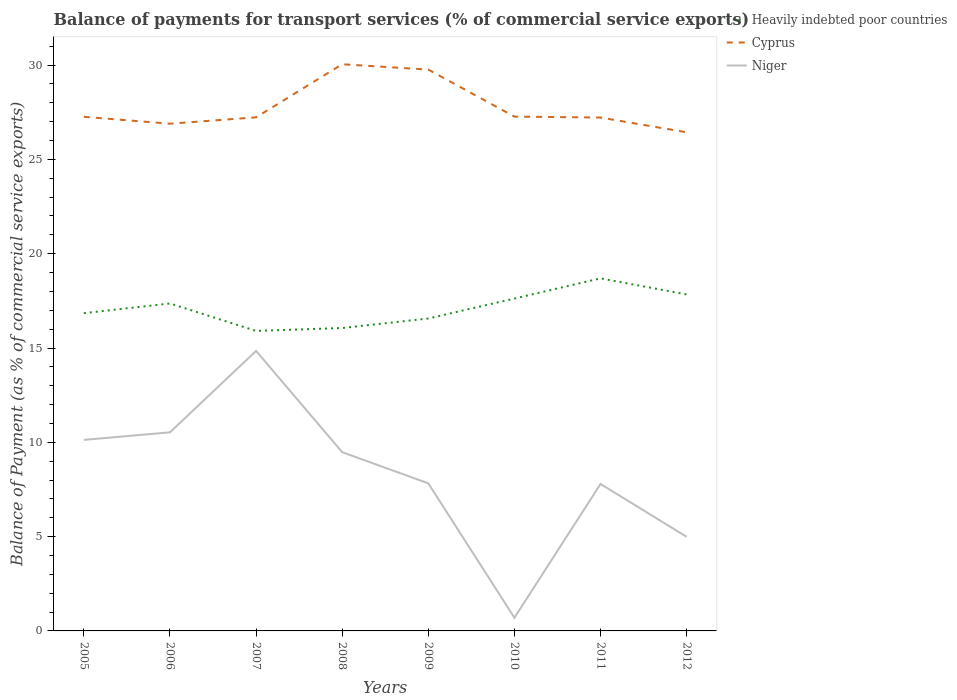How many different coloured lines are there?
Offer a very short reply. 3. Does the line corresponding to Cyprus intersect with the line corresponding to Niger?
Your answer should be very brief. No. Across all years, what is the maximum balance of payments for transport services in Heavily indebted poor countries?
Your answer should be compact. 15.91. In which year was the balance of payments for transport services in Heavily indebted poor countries maximum?
Give a very brief answer. 2007. What is the total balance of payments for transport services in Cyprus in the graph?
Provide a short and direct response. 2.54. What is the difference between the highest and the second highest balance of payments for transport services in Cyprus?
Offer a very short reply. 3.61. Is the balance of payments for transport services in Heavily indebted poor countries strictly greater than the balance of payments for transport services in Cyprus over the years?
Ensure brevity in your answer.  Yes. Are the values on the major ticks of Y-axis written in scientific E-notation?
Ensure brevity in your answer.  No. Does the graph contain any zero values?
Your response must be concise. No. Does the graph contain grids?
Your answer should be very brief. No. Where does the legend appear in the graph?
Ensure brevity in your answer.  Top right. What is the title of the graph?
Provide a short and direct response. Balance of payments for transport services (% of commercial service exports). What is the label or title of the X-axis?
Provide a succinct answer. Years. What is the label or title of the Y-axis?
Offer a terse response. Balance of Payment (as % of commercial service exports). What is the Balance of Payment (as % of commercial service exports) in Heavily indebted poor countries in 2005?
Give a very brief answer. 16.85. What is the Balance of Payment (as % of commercial service exports) of Cyprus in 2005?
Give a very brief answer. 27.26. What is the Balance of Payment (as % of commercial service exports) in Niger in 2005?
Your answer should be very brief. 10.13. What is the Balance of Payment (as % of commercial service exports) in Heavily indebted poor countries in 2006?
Give a very brief answer. 17.36. What is the Balance of Payment (as % of commercial service exports) of Cyprus in 2006?
Offer a terse response. 26.89. What is the Balance of Payment (as % of commercial service exports) in Niger in 2006?
Your answer should be compact. 10.53. What is the Balance of Payment (as % of commercial service exports) of Heavily indebted poor countries in 2007?
Make the answer very short. 15.91. What is the Balance of Payment (as % of commercial service exports) in Cyprus in 2007?
Give a very brief answer. 27.23. What is the Balance of Payment (as % of commercial service exports) of Niger in 2007?
Ensure brevity in your answer.  14.85. What is the Balance of Payment (as % of commercial service exports) in Heavily indebted poor countries in 2008?
Your answer should be compact. 16.06. What is the Balance of Payment (as % of commercial service exports) of Cyprus in 2008?
Your answer should be very brief. 30.05. What is the Balance of Payment (as % of commercial service exports) in Niger in 2008?
Offer a very short reply. 9.48. What is the Balance of Payment (as % of commercial service exports) of Heavily indebted poor countries in 2009?
Ensure brevity in your answer.  16.57. What is the Balance of Payment (as % of commercial service exports) of Cyprus in 2009?
Ensure brevity in your answer.  29.76. What is the Balance of Payment (as % of commercial service exports) of Niger in 2009?
Your answer should be very brief. 7.82. What is the Balance of Payment (as % of commercial service exports) of Heavily indebted poor countries in 2010?
Your response must be concise. 17.62. What is the Balance of Payment (as % of commercial service exports) of Cyprus in 2010?
Your response must be concise. 27.27. What is the Balance of Payment (as % of commercial service exports) of Niger in 2010?
Give a very brief answer. 0.7. What is the Balance of Payment (as % of commercial service exports) in Heavily indebted poor countries in 2011?
Provide a succinct answer. 18.69. What is the Balance of Payment (as % of commercial service exports) of Cyprus in 2011?
Your answer should be very brief. 27.22. What is the Balance of Payment (as % of commercial service exports) of Niger in 2011?
Offer a very short reply. 7.79. What is the Balance of Payment (as % of commercial service exports) of Heavily indebted poor countries in 2012?
Offer a terse response. 17.84. What is the Balance of Payment (as % of commercial service exports) of Cyprus in 2012?
Offer a very short reply. 26.44. What is the Balance of Payment (as % of commercial service exports) of Niger in 2012?
Make the answer very short. 4.99. Across all years, what is the maximum Balance of Payment (as % of commercial service exports) in Heavily indebted poor countries?
Provide a short and direct response. 18.69. Across all years, what is the maximum Balance of Payment (as % of commercial service exports) of Cyprus?
Your response must be concise. 30.05. Across all years, what is the maximum Balance of Payment (as % of commercial service exports) in Niger?
Provide a succinct answer. 14.85. Across all years, what is the minimum Balance of Payment (as % of commercial service exports) in Heavily indebted poor countries?
Make the answer very short. 15.91. Across all years, what is the minimum Balance of Payment (as % of commercial service exports) in Cyprus?
Provide a short and direct response. 26.44. Across all years, what is the minimum Balance of Payment (as % of commercial service exports) in Niger?
Your response must be concise. 0.7. What is the total Balance of Payment (as % of commercial service exports) of Heavily indebted poor countries in the graph?
Offer a very short reply. 136.9. What is the total Balance of Payment (as % of commercial service exports) of Cyprus in the graph?
Give a very brief answer. 222.12. What is the total Balance of Payment (as % of commercial service exports) of Niger in the graph?
Your response must be concise. 66.29. What is the difference between the Balance of Payment (as % of commercial service exports) in Heavily indebted poor countries in 2005 and that in 2006?
Offer a very short reply. -0.51. What is the difference between the Balance of Payment (as % of commercial service exports) of Cyprus in 2005 and that in 2006?
Your answer should be compact. 0.36. What is the difference between the Balance of Payment (as % of commercial service exports) in Niger in 2005 and that in 2006?
Your answer should be very brief. -0.4. What is the difference between the Balance of Payment (as % of commercial service exports) of Heavily indebted poor countries in 2005 and that in 2007?
Keep it short and to the point. 0.94. What is the difference between the Balance of Payment (as % of commercial service exports) of Cyprus in 2005 and that in 2007?
Keep it short and to the point. 0.03. What is the difference between the Balance of Payment (as % of commercial service exports) in Niger in 2005 and that in 2007?
Your response must be concise. -4.72. What is the difference between the Balance of Payment (as % of commercial service exports) of Heavily indebted poor countries in 2005 and that in 2008?
Offer a very short reply. 0.79. What is the difference between the Balance of Payment (as % of commercial service exports) of Cyprus in 2005 and that in 2008?
Ensure brevity in your answer.  -2.79. What is the difference between the Balance of Payment (as % of commercial service exports) in Niger in 2005 and that in 2008?
Give a very brief answer. 0.65. What is the difference between the Balance of Payment (as % of commercial service exports) in Heavily indebted poor countries in 2005 and that in 2009?
Your answer should be compact. 0.28. What is the difference between the Balance of Payment (as % of commercial service exports) in Cyprus in 2005 and that in 2009?
Give a very brief answer. -2.5. What is the difference between the Balance of Payment (as % of commercial service exports) in Niger in 2005 and that in 2009?
Give a very brief answer. 2.3. What is the difference between the Balance of Payment (as % of commercial service exports) in Heavily indebted poor countries in 2005 and that in 2010?
Your answer should be very brief. -0.78. What is the difference between the Balance of Payment (as % of commercial service exports) in Cyprus in 2005 and that in 2010?
Give a very brief answer. -0.01. What is the difference between the Balance of Payment (as % of commercial service exports) in Niger in 2005 and that in 2010?
Keep it short and to the point. 9.43. What is the difference between the Balance of Payment (as % of commercial service exports) of Heavily indebted poor countries in 2005 and that in 2011?
Keep it short and to the point. -1.85. What is the difference between the Balance of Payment (as % of commercial service exports) in Cyprus in 2005 and that in 2011?
Keep it short and to the point. 0.04. What is the difference between the Balance of Payment (as % of commercial service exports) of Niger in 2005 and that in 2011?
Your answer should be very brief. 2.34. What is the difference between the Balance of Payment (as % of commercial service exports) in Heavily indebted poor countries in 2005 and that in 2012?
Ensure brevity in your answer.  -0.99. What is the difference between the Balance of Payment (as % of commercial service exports) of Cyprus in 2005 and that in 2012?
Make the answer very short. 0.82. What is the difference between the Balance of Payment (as % of commercial service exports) of Niger in 2005 and that in 2012?
Make the answer very short. 5.14. What is the difference between the Balance of Payment (as % of commercial service exports) in Heavily indebted poor countries in 2006 and that in 2007?
Provide a short and direct response. 1.45. What is the difference between the Balance of Payment (as % of commercial service exports) of Cyprus in 2006 and that in 2007?
Offer a terse response. -0.34. What is the difference between the Balance of Payment (as % of commercial service exports) of Niger in 2006 and that in 2007?
Keep it short and to the point. -4.32. What is the difference between the Balance of Payment (as % of commercial service exports) in Cyprus in 2006 and that in 2008?
Provide a succinct answer. -3.15. What is the difference between the Balance of Payment (as % of commercial service exports) in Niger in 2006 and that in 2008?
Provide a succinct answer. 1.05. What is the difference between the Balance of Payment (as % of commercial service exports) in Heavily indebted poor countries in 2006 and that in 2009?
Your answer should be very brief. 0.79. What is the difference between the Balance of Payment (as % of commercial service exports) of Cyprus in 2006 and that in 2009?
Make the answer very short. -2.87. What is the difference between the Balance of Payment (as % of commercial service exports) of Niger in 2006 and that in 2009?
Give a very brief answer. 2.71. What is the difference between the Balance of Payment (as % of commercial service exports) of Heavily indebted poor countries in 2006 and that in 2010?
Your answer should be very brief. -0.26. What is the difference between the Balance of Payment (as % of commercial service exports) in Cyprus in 2006 and that in 2010?
Provide a short and direct response. -0.38. What is the difference between the Balance of Payment (as % of commercial service exports) of Niger in 2006 and that in 2010?
Offer a terse response. 9.83. What is the difference between the Balance of Payment (as % of commercial service exports) of Heavily indebted poor countries in 2006 and that in 2011?
Your answer should be compact. -1.33. What is the difference between the Balance of Payment (as % of commercial service exports) in Cyprus in 2006 and that in 2011?
Offer a terse response. -0.33. What is the difference between the Balance of Payment (as % of commercial service exports) of Niger in 2006 and that in 2011?
Your response must be concise. 2.74. What is the difference between the Balance of Payment (as % of commercial service exports) in Heavily indebted poor countries in 2006 and that in 2012?
Provide a short and direct response. -0.48. What is the difference between the Balance of Payment (as % of commercial service exports) in Cyprus in 2006 and that in 2012?
Your response must be concise. 0.45. What is the difference between the Balance of Payment (as % of commercial service exports) of Niger in 2006 and that in 2012?
Make the answer very short. 5.54. What is the difference between the Balance of Payment (as % of commercial service exports) of Heavily indebted poor countries in 2007 and that in 2008?
Make the answer very short. -0.15. What is the difference between the Balance of Payment (as % of commercial service exports) in Cyprus in 2007 and that in 2008?
Keep it short and to the point. -2.81. What is the difference between the Balance of Payment (as % of commercial service exports) of Niger in 2007 and that in 2008?
Make the answer very short. 5.37. What is the difference between the Balance of Payment (as % of commercial service exports) of Heavily indebted poor countries in 2007 and that in 2009?
Offer a terse response. -0.66. What is the difference between the Balance of Payment (as % of commercial service exports) in Cyprus in 2007 and that in 2009?
Ensure brevity in your answer.  -2.53. What is the difference between the Balance of Payment (as % of commercial service exports) in Niger in 2007 and that in 2009?
Your answer should be compact. 7.02. What is the difference between the Balance of Payment (as % of commercial service exports) in Heavily indebted poor countries in 2007 and that in 2010?
Give a very brief answer. -1.72. What is the difference between the Balance of Payment (as % of commercial service exports) in Cyprus in 2007 and that in 2010?
Your answer should be compact. -0.04. What is the difference between the Balance of Payment (as % of commercial service exports) in Niger in 2007 and that in 2010?
Offer a terse response. 14.15. What is the difference between the Balance of Payment (as % of commercial service exports) of Heavily indebted poor countries in 2007 and that in 2011?
Your answer should be compact. -2.79. What is the difference between the Balance of Payment (as % of commercial service exports) in Cyprus in 2007 and that in 2011?
Ensure brevity in your answer.  0.01. What is the difference between the Balance of Payment (as % of commercial service exports) in Niger in 2007 and that in 2011?
Offer a very short reply. 7.05. What is the difference between the Balance of Payment (as % of commercial service exports) in Heavily indebted poor countries in 2007 and that in 2012?
Provide a succinct answer. -1.93. What is the difference between the Balance of Payment (as % of commercial service exports) in Cyprus in 2007 and that in 2012?
Your answer should be very brief. 0.79. What is the difference between the Balance of Payment (as % of commercial service exports) of Niger in 2007 and that in 2012?
Offer a very short reply. 9.86. What is the difference between the Balance of Payment (as % of commercial service exports) in Heavily indebted poor countries in 2008 and that in 2009?
Your response must be concise. -0.51. What is the difference between the Balance of Payment (as % of commercial service exports) in Cyprus in 2008 and that in 2009?
Provide a short and direct response. 0.28. What is the difference between the Balance of Payment (as % of commercial service exports) in Niger in 2008 and that in 2009?
Give a very brief answer. 1.65. What is the difference between the Balance of Payment (as % of commercial service exports) in Heavily indebted poor countries in 2008 and that in 2010?
Offer a terse response. -1.56. What is the difference between the Balance of Payment (as % of commercial service exports) of Cyprus in 2008 and that in 2010?
Make the answer very short. 2.78. What is the difference between the Balance of Payment (as % of commercial service exports) of Niger in 2008 and that in 2010?
Provide a short and direct response. 8.78. What is the difference between the Balance of Payment (as % of commercial service exports) of Heavily indebted poor countries in 2008 and that in 2011?
Your response must be concise. -2.63. What is the difference between the Balance of Payment (as % of commercial service exports) in Cyprus in 2008 and that in 2011?
Give a very brief answer. 2.83. What is the difference between the Balance of Payment (as % of commercial service exports) of Niger in 2008 and that in 2011?
Offer a terse response. 1.69. What is the difference between the Balance of Payment (as % of commercial service exports) in Heavily indebted poor countries in 2008 and that in 2012?
Your response must be concise. -1.78. What is the difference between the Balance of Payment (as % of commercial service exports) in Cyprus in 2008 and that in 2012?
Make the answer very short. 3.61. What is the difference between the Balance of Payment (as % of commercial service exports) of Niger in 2008 and that in 2012?
Offer a terse response. 4.49. What is the difference between the Balance of Payment (as % of commercial service exports) in Heavily indebted poor countries in 2009 and that in 2010?
Offer a terse response. -1.06. What is the difference between the Balance of Payment (as % of commercial service exports) in Cyprus in 2009 and that in 2010?
Your response must be concise. 2.49. What is the difference between the Balance of Payment (as % of commercial service exports) in Niger in 2009 and that in 2010?
Give a very brief answer. 7.12. What is the difference between the Balance of Payment (as % of commercial service exports) of Heavily indebted poor countries in 2009 and that in 2011?
Make the answer very short. -2.13. What is the difference between the Balance of Payment (as % of commercial service exports) of Cyprus in 2009 and that in 2011?
Provide a short and direct response. 2.54. What is the difference between the Balance of Payment (as % of commercial service exports) in Niger in 2009 and that in 2011?
Keep it short and to the point. 0.03. What is the difference between the Balance of Payment (as % of commercial service exports) in Heavily indebted poor countries in 2009 and that in 2012?
Offer a terse response. -1.27. What is the difference between the Balance of Payment (as % of commercial service exports) of Cyprus in 2009 and that in 2012?
Make the answer very short. 3.32. What is the difference between the Balance of Payment (as % of commercial service exports) in Niger in 2009 and that in 2012?
Your answer should be very brief. 2.83. What is the difference between the Balance of Payment (as % of commercial service exports) of Heavily indebted poor countries in 2010 and that in 2011?
Your answer should be compact. -1.07. What is the difference between the Balance of Payment (as % of commercial service exports) of Cyprus in 2010 and that in 2011?
Provide a short and direct response. 0.05. What is the difference between the Balance of Payment (as % of commercial service exports) of Niger in 2010 and that in 2011?
Your response must be concise. -7.09. What is the difference between the Balance of Payment (as % of commercial service exports) in Heavily indebted poor countries in 2010 and that in 2012?
Your answer should be compact. -0.22. What is the difference between the Balance of Payment (as % of commercial service exports) of Cyprus in 2010 and that in 2012?
Make the answer very short. 0.83. What is the difference between the Balance of Payment (as % of commercial service exports) in Niger in 2010 and that in 2012?
Ensure brevity in your answer.  -4.29. What is the difference between the Balance of Payment (as % of commercial service exports) of Heavily indebted poor countries in 2011 and that in 2012?
Provide a short and direct response. 0.85. What is the difference between the Balance of Payment (as % of commercial service exports) in Cyprus in 2011 and that in 2012?
Your response must be concise. 0.78. What is the difference between the Balance of Payment (as % of commercial service exports) of Niger in 2011 and that in 2012?
Keep it short and to the point. 2.8. What is the difference between the Balance of Payment (as % of commercial service exports) of Heavily indebted poor countries in 2005 and the Balance of Payment (as % of commercial service exports) of Cyprus in 2006?
Your answer should be compact. -10.05. What is the difference between the Balance of Payment (as % of commercial service exports) in Heavily indebted poor countries in 2005 and the Balance of Payment (as % of commercial service exports) in Niger in 2006?
Your response must be concise. 6.32. What is the difference between the Balance of Payment (as % of commercial service exports) in Cyprus in 2005 and the Balance of Payment (as % of commercial service exports) in Niger in 2006?
Your answer should be compact. 16.73. What is the difference between the Balance of Payment (as % of commercial service exports) of Heavily indebted poor countries in 2005 and the Balance of Payment (as % of commercial service exports) of Cyprus in 2007?
Your response must be concise. -10.38. What is the difference between the Balance of Payment (as % of commercial service exports) in Heavily indebted poor countries in 2005 and the Balance of Payment (as % of commercial service exports) in Niger in 2007?
Your answer should be very brief. 2. What is the difference between the Balance of Payment (as % of commercial service exports) in Cyprus in 2005 and the Balance of Payment (as % of commercial service exports) in Niger in 2007?
Give a very brief answer. 12.41. What is the difference between the Balance of Payment (as % of commercial service exports) of Heavily indebted poor countries in 2005 and the Balance of Payment (as % of commercial service exports) of Cyprus in 2008?
Keep it short and to the point. -13.2. What is the difference between the Balance of Payment (as % of commercial service exports) in Heavily indebted poor countries in 2005 and the Balance of Payment (as % of commercial service exports) in Niger in 2008?
Offer a terse response. 7.37. What is the difference between the Balance of Payment (as % of commercial service exports) in Cyprus in 2005 and the Balance of Payment (as % of commercial service exports) in Niger in 2008?
Make the answer very short. 17.78. What is the difference between the Balance of Payment (as % of commercial service exports) of Heavily indebted poor countries in 2005 and the Balance of Payment (as % of commercial service exports) of Cyprus in 2009?
Provide a succinct answer. -12.91. What is the difference between the Balance of Payment (as % of commercial service exports) of Heavily indebted poor countries in 2005 and the Balance of Payment (as % of commercial service exports) of Niger in 2009?
Your response must be concise. 9.02. What is the difference between the Balance of Payment (as % of commercial service exports) in Cyprus in 2005 and the Balance of Payment (as % of commercial service exports) in Niger in 2009?
Offer a very short reply. 19.43. What is the difference between the Balance of Payment (as % of commercial service exports) of Heavily indebted poor countries in 2005 and the Balance of Payment (as % of commercial service exports) of Cyprus in 2010?
Provide a succinct answer. -10.42. What is the difference between the Balance of Payment (as % of commercial service exports) in Heavily indebted poor countries in 2005 and the Balance of Payment (as % of commercial service exports) in Niger in 2010?
Give a very brief answer. 16.15. What is the difference between the Balance of Payment (as % of commercial service exports) of Cyprus in 2005 and the Balance of Payment (as % of commercial service exports) of Niger in 2010?
Give a very brief answer. 26.56. What is the difference between the Balance of Payment (as % of commercial service exports) of Heavily indebted poor countries in 2005 and the Balance of Payment (as % of commercial service exports) of Cyprus in 2011?
Offer a terse response. -10.37. What is the difference between the Balance of Payment (as % of commercial service exports) in Heavily indebted poor countries in 2005 and the Balance of Payment (as % of commercial service exports) in Niger in 2011?
Make the answer very short. 9.06. What is the difference between the Balance of Payment (as % of commercial service exports) in Cyprus in 2005 and the Balance of Payment (as % of commercial service exports) in Niger in 2011?
Keep it short and to the point. 19.47. What is the difference between the Balance of Payment (as % of commercial service exports) of Heavily indebted poor countries in 2005 and the Balance of Payment (as % of commercial service exports) of Cyprus in 2012?
Ensure brevity in your answer.  -9.59. What is the difference between the Balance of Payment (as % of commercial service exports) of Heavily indebted poor countries in 2005 and the Balance of Payment (as % of commercial service exports) of Niger in 2012?
Ensure brevity in your answer.  11.86. What is the difference between the Balance of Payment (as % of commercial service exports) in Cyprus in 2005 and the Balance of Payment (as % of commercial service exports) in Niger in 2012?
Keep it short and to the point. 22.27. What is the difference between the Balance of Payment (as % of commercial service exports) of Heavily indebted poor countries in 2006 and the Balance of Payment (as % of commercial service exports) of Cyprus in 2007?
Your answer should be compact. -9.87. What is the difference between the Balance of Payment (as % of commercial service exports) in Heavily indebted poor countries in 2006 and the Balance of Payment (as % of commercial service exports) in Niger in 2007?
Give a very brief answer. 2.51. What is the difference between the Balance of Payment (as % of commercial service exports) of Cyprus in 2006 and the Balance of Payment (as % of commercial service exports) of Niger in 2007?
Your response must be concise. 12.05. What is the difference between the Balance of Payment (as % of commercial service exports) in Heavily indebted poor countries in 2006 and the Balance of Payment (as % of commercial service exports) in Cyprus in 2008?
Your answer should be very brief. -12.69. What is the difference between the Balance of Payment (as % of commercial service exports) in Heavily indebted poor countries in 2006 and the Balance of Payment (as % of commercial service exports) in Niger in 2008?
Provide a succinct answer. 7.88. What is the difference between the Balance of Payment (as % of commercial service exports) of Cyprus in 2006 and the Balance of Payment (as % of commercial service exports) of Niger in 2008?
Offer a terse response. 17.42. What is the difference between the Balance of Payment (as % of commercial service exports) in Heavily indebted poor countries in 2006 and the Balance of Payment (as % of commercial service exports) in Cyprus in 2009?
Your answer should be very brief. -12.4. What is the difference between the Balance of Payment (as % of commercial service exports) in Heavily indebted poor countries in 2006 and the Balance of Payment (as % of commercial service exports) in Niger in 2009?
Your answer should be very brief. 9.54. What is the difference between the Balance of Payment (as % of commercial service exports) of Cyprus in 2006 and the Balance of Payment (as % of commercial service exports) of Niger in 2009?
Offer a very short reply. 19.07. What is the difference between the Balance of Payment (as % of commercial service exports) in Heavily indebted poor countries in 2006 and the Balance of Payment (as % of commercial service exports) in Cyprus in 2010?
Your response must be concise. -9.91. What is the difference between the Balance of Payment (as % of commercial service exports) in Heavily indebted poor countries in 2006 and the Balance of Payment (as % of commercial service exports) in Niger in 2010?
Your answer should be compact. 16.66. What is the difference between the Balance of Payment (as % of commercial service exports) of Cyprus in 2006 and the Balance of Payment (as % of commercial service exports) of Niger in 2010?
Ensure brevity in your answer.  26.19. What is the difference between the Balance of Payment (as % of commercial service exports) in Heavily indebted poor countries in 2006 and the Balance of Payment (as % of commercial service exports) in Cyprus in 2011?
Offer a very short reply. -9.86. What is the difference between the Balance of Payment (as % of commercial service exports) of Heavily indebted poor countries in 2006 and the Balance of Payment (as % of commercial service exports) of Niger in 2011?
Your answer should be very brief. 9.57. What is the difference between the Balance of Payment (as % of commercial service exports) of Cyprus in 2006 and the Balance of Payment (as % of commercial service exports) of Niger in 2011?
Provide a succinct answer. 19.1. What is the difference between the Balance of Payment (as % of commercial service exports) of Heavily indebted poor countries in 2006 and the Balance of Payment (as % of commercial service exports) of Cyprus in 2012?
Provide a succinct answer. -9.08. What is the difference between the Balance of Payment (as % of commercial service exports) of Heavily indebted poor countries in 2006 and the Balance of Payment (as % of commercial service exports) of Niger in 2012?
Your answer should be very brief. 12.37. What is the difference between the Balance of Payment (as % of commercial service exports) of Cyprus in 2006 and the Balance of Payment (as % of commercial service exports) of Niger in 2012?
Provide a short and direct response. 21.9. What is the difference between the Balance of Payment (as % of commercial service exports) of Heavily indebted poor countries in 2007 and the Balance of Payment (as % of commercial service exports) of Cyprus in 2008?
Your answer should be very brief. -14.14. What is the difference between the Balance of Payment (as % of commercial service exports) in Heavily indebted poor countries in 2007 and the Balance of Payment (as % of commercial service exports) in Niger in 2008?
Ensure brevity in your answer.  6.43. What is the difference between the Balance of Payment (as % of commercial service exports) of Cyprus in 2007 and the Balance of Payment (as % of commercial service exports) of Niger in 2008?
Ensure brevity in your answer.  17.75. What is the difference between the Balance of Payment (as % of commercial service exports) in Heavily indebted poor countries in 2007 and the Balance of Payment (as % of commercial service exports) in Cyprus in 2009?
Offer a terse response. -13.86. What is the difference between the Balance of Payment (as % of commercial service exports) in Heavily indebted poor countries in 2007 and the Balance of Payment (as % of commercial service exports) in Niger in 2009?
Ensure brevity in your answer.  8.08. What is the difference between the Balance of Payment (as % of commercial service exports) of Cyprus in 2007 and the Balance of Payment (as % of commercial service exports) of Niger in 2009?
Give a very brief answer. 19.41. What is the difference between the Balance of Payment (as % of commercial service exports) in Heavily indebted poor countries in 2007 and the Balance of Payment (as % of commercial service exports) in Cyprus in 2010?
Your answer should be compact. -11.36. What is the difference between the Balance of Payment (as % of commercial service exports) of Heavily indebted poor countries in 2007 and the Balance of Payment (as % of commercial service exports) of Niger in 2010?
Make the answer very short. 15.21. What is the difference between the Balance of Payment (as % of commercial service exports) of Cyprus in 2007 and the Balance of Payment (as % of commercial service exports) of Niger in 2010?
Your answer should be compact. 26.53. What is the difference between the Balance of Payment (as % of commercial service exports) of Heavily indebted poor countries in 2007 and the Balance of Payment (as % of commercial service exports) of Cyprus in 2011?
Your answer should be very brief. -11.31. What is the difference between the Balance of Payment (as % of commercial service exports) of Heavily indebted poor countries in 2007 and the Balance of Payment (as % of commercial service exports) of Niger in 2011?
Your answer should be very brief. 8.11. What is the difference between the Balance of Payment (as % of commercial service exports) in Cyprus in 2007 and the Balance of Payment (as % of commercial service exports) in Niger in 2011?
Your answer should be very brief. 19.44. What is the difference between the Balance of Payment (as % of commercial service exports) of Heavily indebted poor countries in 2007 and the Balance of Payment (as % of commercial service exports) of Cyprus in 2012?
Keep it short and to the point. -10.53. What is the difference between the Balance of Payment (as % of commercial service exports) in Heavily indebted poor countries in 2007 and the Balance of Payment (as % of commercial service exports) in Niger in 2012?
Your answer should be compact. 10.92. What is the difference between the Balance of Payment (as % of commercial service exports) of Cyprus in 2007 and the Balance of Payment (as % of commercial service exports) of Niger in 2012?
Offer a terse response. 22.24. What is the difference between the Balance of Payment (as % of commercial service exports) in Heavily indebted poor countries in 2008 and the Balance of Payment (as % of commercial service exports) in Cyprus in 2009?
Provide a succinct answer. -13.7. What is the difference between the Balance of Payment (as % of commercial service exports) of Heavily indebted poor countries in 2008 and the Balance of Payment (as % of commercial service exports) of Niger in 2009?
Provide a short and direct response. 8.24. What is the difference between the Balance of Payment (as % of commercial service exports) in Cyprus in 2008 and the Balance of Payment (as % of commercial service exports) in Niger in 2009?
Make the answer very short. 22.22. What is the difference between the Balance of Payment (as % of commercial service exports) of Heavily indebted poor countries in 2008 and the Balance of Payment (as % of commercial service exports) of Cyprus in 2010?
Keep it short and to the point. -11.21. What is the difference between the Balance of Payment (as % of commercial service exports) of Heavily indebted poor countries in 2008 and the Balance of Payment (as % of commercial service exports) of Niger in 2010?
Give a very brief answer. 15.36. What is the difference between the Balance of Payment (as % of commercial service exports) in Cyprus in 2008 and the Balance of Payment (as % of commercial service exports) in Niger in 2010?
Your response must be concise. 29.35. What is the difference between the Balance of Payment (as % of commercial service exports) of Heavily indebted poor countries in 2008 and the Balance of Payment (as % of commercial service exports) of Cyprus in 2011?
Your answer should be very brief. -11.16. What is the difference between the Balance of Payment (as % of commercial service exports) of Heavily indebted poor countries in 2008 and the Balance of Payment (as % of commercial service exports) of Niger in 2011?
Ensure brevity in your answer.  8.27. What is the difference between the Balance of Payment (as % of commercial service exports) of Cyprus in 2008 and the Balance of Payment (as % of commercial service exports) of Niger in 2011?
Give a very brief answer. 22.25. What is the difference between the Balance of Payment (as % of commercial service exports) in Heavily indebted poor countries in 2008 and the Balance of Payment (as % of commercial service exports) in Cyprus in 2012?
Your answer should be very brief. -10.38. What is the difference between the Balance of Payment (as % of commercial service exports) of Heavily indebted poor countries in 2008 and the Balance of Payment (as % of commercial service exports) of Niger in 2012?
Make the answer very short. 11.07. What is the difference between the Balance of Payment (as % of commercial service exports) in Cyprus in 2008 and the Balance of Payment (as % of commercial service exports) in Niger in 2012?
Your response must be concise. 25.06. What is the difference between the Balance of Payment (as % of commercial service exports) of Heavily indebted poor countries in 2009 and the Balance of Payment (as % of commercial service exports) of Cyprus in 2010?
Offer a terse response. -10.7. What is the difference between the Balance of Payment (as % of commercial service exports) of Heavily indebted poor countries in 2009 and the Balance of Payment (as % of commercial service exports) of Niger in 2010?
Give a very brief answer. 15.87. What is the difference between the Balance of Payment (as % of commercial service exports) in Cyprus in 2009 and the Balance of Payment (as % of commercial service exports) in Niger in 2010?
Offer a terse response. 29.06. What is the difference between the Balance of Payment (as % of commercial service exports) of Heavily indebted poor countries in 2009 and the Balance of Payment (as % of commercial service exports) of Cyprus in 2011?
Offer a terse response. -10.65. What is the difference between the Balance of Payment (as % of commercial service exports) in Heavily indebted poor countries in 2009 and the Balance of Payment (as % of commercial service exports) in Niger in 2011?
Your answer should be very brief. 8.77. What is the difference between the Balance of Payment (as % of commercial service exports) in Cyprus in 2009 and the Balance of Payment (as % of commercial service exports) in Niger in 2011?
Provide a succinct answer. 21.97. What is the difference between the Balance of Payment (as % of commercial service exports) in Heavily indebted poor countries in 2009 and the Balance of Payment (as % of commercial service exports) in Cyprus in 2012?
Your answer should be compact. -9.87. What is the difference between the Balance of Payment (as % of commercial service exports) of Heavily indebted poor countries in 2009 and the Balance of Payment (as % of commercial service exports) of Niger in 2012?
Offer a terse response. 11.58. What is the difference between the Balance of Payment (as % of commercial service exports) in Cyprus in 2009 and the Balance of Payment (as % of commercial service exports) in Niger in 2012?
Offer a terse response. 24.77. What is the difference between the Balance of Payment (as % of commercial service exports) in Heavily indebted poor countries in 2010 and the Balance of Payment (as % of commercial service exports) in Cyprus in 2011?
Keep it short and to the point. -9.6. What is the difference between the Balance of Payment (as % of commercial service exports) in Heavily indebted poor countries in 2010 and the Balance of Payment (as % of commercial service exports) in Niger in 2011?
Your response must be concise. 9.83. What is the difference between the Balance of Payment (as % of commercial service exports) of Cyprus in 2010 and the Balance of Payment (as % of commercial service exports) of Niger in 2011?
Ensure brevity in your answer.  19.48. What is the difference between the Balance of Payment (as % of commercial service exports) of Heavily indebted poor countries in 2010 and the Balance of Payment (as % of commercial service exports) of Cyprus in 2012?
Offer a terse response. -8.82. What is the difference between the Balance of Payment (as % of commercial service exports) of Heavily indebted poor countries in 2010 and the Balance of Payment (as % of commercial service exports) of Niger in 2012?
Your answer should be very brief. 12.63. What is the difference between the Balance of Payment (as % of commercial service exports) of Cyprus in 2010 and the Balance of Payment (as % of commercial service exports) of Niger in 2012?
Keep it short and to the point. 22.28. What is the difference between the Balance of Payment (as % of commercial service exports) of Heavily indebted poor countries in 2011 and the Balance of Payment (as % of commercial service exports) of Cyprus in 2012?
Offer a terse response. -7.75. What is the difference between the Balance of Payment (as % of commercial service exports) in Heavily indebted poor countries in 2011 and the Balance of Payment (as % of commercial service exports) in Niger in 2012?
Give a very brief answer. 13.7. What is the difference between the Balance of Payment (as % of commercial service exports) in Cyprus in 2011 and the Balance of Payment (as % of commercial service exports) in Niger in 2012?
Give a very brief answer. 22.23. What is the average Balance of Payment (as % of commercial service exports) in Heavily indebted poor countries per year?
Provide a short and direct response. 17.11. What is the average Balance of Payment (as % of commercial service exports) of Cyprus per year?
Ensure brevity in your answer.  27.76. What is the average Balance of Payment (as % of commercial service exports) in Niger per year?
Give a very brief answer. 8.29. In the year 2005, what is the difference between the Balance of Payment (as % of commercial service exports) in Heavily indebted poor countries and Balance of Payment (as % of commercial service exports) in Cyprus?
Give a very brief answer. -10.41. In the year 2005, what is the difference between the Balance of Payment (as % of commercial service exports) in Heavily indebted poor countries and Balance of Payment (as % of commercial service exports) in Niger?
Provide a succinct answer. 6.72. In the year 2005, what is the difference between the Balance of Payment (as % of commercial service exports) in Cyprus and Balance of Payment (as % of commercial service exports) in Niger?
Give a very brief answer. 17.13. In the year 2006, what is the difference between the Balance of Payment (as % of commercial service exports) in Heavily indebted poor countries and Balance of Payment (as % of commercial service exports) in Cyprus?
Keep it short and to the point. -9.53. In the year 2006, what is the difference between the Balance of Payment (as % of commercial service exports) of Heavily indebted poor countries and Balance of Payment (as % of commercial service exports) of Niger?
Make the answer very short. 6.83. In the year 2006, what is the difference between the Balance of Payment (as % of commercial service exports) of Cyprus and Balance of Payment (as % of commercial service exports) of Niger?
Offer a terse response. 16.36. In the year 2007, what is the difference between the Balance of Payment (as % of commercial service exports) of Heavily indebted poor countries and Balance of Payment (as % of commercial service exports) of Cyprus?
Offer a very short reply. -11.32. In the year 2007, what is the difference between the Balance of Payment (as % of commercial service exports) in Heavily indebted poor countries and Balance of Payment (as % of commercial service exports) in Niger?
Make the answer very short. 1.06. In the year 2007, what is the difference between the Balance of Payment (as % of commercial service exports) in Cyprus and Balance of Payment (as % of commercial service exports) in Niger?
Make the answer very short. 12.38. In the year 2008, what is the difference between the Balance of Payment (as % of commercial service exports) of Heavily indebted poor countries and Balance of Payment (as % of commercial service exports) of Cyprus?
Make the answer very short. -13.99. In the year 2008, what is the difference between the Balance of Payment (as % of commercial service exports) of Heavily indebted poor countries and Balance of Payment (as % of commercial service exports) of Niger?
Provide a short and direct response. 6.58. In the year 2008, what is the difference between the Balance of Payment (as % of commercial service exports) in Cyprus and Balance of Payment (as % of commercial service exports) in Niger?
Provide a succinct answer. 20.57. In the year 2009, what is the difference between the Balance of Payment (as % of commercial service exports) of Heavily indebted poor countries and Balance of Payment (as % of commercial service exports) of Cyprus?
Provide a short and direct response. -13.2. In the year 2009, what is the difference between the Balance of Payment (as % of commercial service exports) in Heavily indebted poor countries and Balance of Payment (as % of commercial service exports) in Niger?
Provide a succinct answer. 8.74. In the year 2009, what is the difference between the Balance of Payment (as % of commercial service exports) of Cyprus and Balance of Payment (as % of commercial service exports) of Niger?
Give a very brief answer. 21.94. In the year 2010, what is the difference between the Balance of Payment (as % of commercial service exports) of Heavily indebted poor countries and Balance of Payment (as % of commercial service exports) of Cyprus?
Your answer should be very brief. -9.65. In the year 2010, what is the difference between the Balance of Payment (as % of commercial service exports) in Heavily indebted poor countries and Balance of Payment (as % of commercial service exports) in Niger?
Keep it short and to the point. 16.92. In the year 2010, what is the difference between the Balance of Payment (as % of commercial service exports) in Cyprus and Balance of Payment (as % of commercial service exports) in Niger?
Your answer should be very brief. 26.57. In the year 2011, what is the difference between the Balance of Payment (as % of commercial service exports) of Heavily indebted poor countries and Balance of Payment (as % of commercial service exports) of Cyprus?
Keep it short and to the point. -8.53. In the year 2011, what is the difference between the Balance of Payment (as % of commercial service exports) in Heavily indebted poor countries and Balance of Payment (as % of commercial service exports) in Niger?
Your answer should be very brief. 10.9. In the year 2011, what is the difference between the Balance of Payment (as % of commercial service exports) in Cyprus and Balance of Payment (as % of commercial service exports) in Niger?
Your answer should be very brief. 19.43. In the year 2012, what is the difference between the Balance of Payment (as % of commercial service exports) of Heavily indebted poor countries and Balance of Payment (as % of commercial service exports) of Cyprus?
Offer a terse response. -8.6. In the year 2012, what is the difference between the Balance of Payment (as % of commercial service exports) in Heavily indebted poor countries and Balance of Payment (as % of commercial service exports) in Niger?
Provide a succinct answer. 12.85. In the year 2012, what is the difference between the Balance of Payment (as % of commercial service exports) in Cyprus and Balance of Payment (as % of commercial service exports) in Niger?
Give a very brief answer. 21.45. What is the ratio of the Balance of Payment (as % of commercial service exports) in Heavily indebted poor countries in 2005 to that in 2006?
Keep it short and to the point. 0.97. What is the ratio of the Balance of Payment (as % of commercial service exports) in Cyprus in 2005 to that in 2006?
Your response must be concise. 1.01. What is the ratio of the Balance of Payment (as % of commercial service exports) in Niger in 2005 to that in 2006?
Give a very brief answer. 0.96. What is the ratio of the Balance of Payment (as % of commercial service exports) of Heavily indebted poor countries in 2005 to that in 2007?
Your answer should be very brief. 1.06. What is the ratio of the Balance of Payment (as % of commercial service exports) in Niger in 2005 to that in 2007?
Keep it short and to the point. 0.68. What is the ratio of the Balance of Payment (as % of commercial service exports) in Heavily indebted poor countries in 2005 to that in 2008?
Provide a succinct answer. 1.05. What is the ratio of the Balance of Payment (as % of commercial service exports) of Cyprus in 2005 to that in 2008?
Provide a succinct answer. 0.91. What is the ratio of the Balance of Payment (as % of commercial service exports) of Niger in 2005 to that in 2008?
Provide a succinct answer. 1.07. What is the ratio of the Balance of Payment (as % of commercial service exports) of Cyprus in 2005 to that in 2009?
Your answer should be compact. 0.92. What is the ratio of the Balance of Payment (as % of commercial service exports) of Niger in 2005 to that in 2009?
Keep it short and to the point. 1.29. What is the ratio of the Balance of Payment (as % of commercial service exports) in Heavily indebted poor countries in 2005 to that in 2010?
Your answer should be compact. 0.96. What is the ratio of the Balance of Payment (as % of commercial service exports) of Cyprus in 2005 to that in 2010?
Offer a terse response. 1. What is the ratio of the Balance of Payment (as % of commercial service exports) of Niger in 2005 to that in 2010?
Ensure brevity in your answer.  14.48. What is the ratio of the Balance of Payment (as % of commercial service exports) in Heavily indebted poor countries in 2005 to that in 2011?
Ensure brevity in your answer.  0.9. What is the ratio of the Balance of Payment (as % of commercial service exports) in Cyprus in 2005 to that in 2011?
Give a very brief answer. 1. What is the ratio of the Balance of Payment (as % of commercial service exports) in Niger in 2005 to that in 2011?
Your response must be concise. 1.3. What is the ratio of the Balance of Payment (as % of commercial service exports) in Heavily indebted poor countries in 2005 to that in 2012?
Your answer should be compact. 0.94. What is the ratio of the Balance of Payment (as % of commercial service exports) in Cyprus in 2005 to that in 2012?
Offer a very short reply. 1.03. What is the ratio of the Balance of Payment (as % of commercial service exports) of Niger in 2005 to that in 2012?
Provide a succinct answer. 2.03. What is the ratio of the Balance of Payment (as % of commercial service exports) in Heavily indebted poor countries in 2006 to that in 2007?
Give a very brief answer. 1.09. What is the ratio of the Balance of Payment (as % of commercial service exports) of Cyprus in 2006 to that in 2007?
Your response must be concise. 0.99. What is the ratio of the Balance of Payment (as % of commercial service exports) in Niger in 2006 to that in 2007?
Make the answer very short. 0.71. What is the ratio of the Balance of Payment (as % of commercial service exports) in Heavily indebted poor countries in 2006 to that in 2008?
Ensure brevity in your answer.  1.08. What is the ratio of the Balance of Payment (as % of commercial service exports) in Cyprus in 2006 to that in 2008?
Offer a terse response. 0.9. What is the ratio of the Balance of Payment (as % of commercial service exports) in Niger in 2006 to that in 2008?
Provide a succinct answer. 1.11. What is the ratio of the Balance of Payment (as % of commercial service exports) in Heavily indebted poor countries in 2006 to that in 2009?
Your response must be concise. 1.05. What is the ratio of the Balance of Payment (as % of commercial service exports) in Cyprus in 2006 to that in 2009?
Offer a very short reply. 0.9. What is the ratio of the Balance of Payment (as % of commercial service exports) in Niger in 2006 to that in 2009?
Ensure brevity in your answer.  1.35. What is the ratio of the Balance of Payment (as % of commercial service exports) in Heavily indebted poor countries in 2006 to that in 2010?
Offer a terse response. 0.99. What is the ratio of the Balance of Payment (as % of commercial service exports) of Cyprus in 2006 to that in 2010?
Give a very brief answer. 0.99. What is the ratio of the Balance of Payment (as % of commercial service exports) in Niger in 2006 to that in 2010?
Your answer should be very brief. 15.05. What is the ratio of the Balance of Payment (as % of commercial service exports) of Heavily indebted poor countries in 2006 to that in 2011?
Provide a succinct answer. 0.93. What is the ratio of the Balance of Payment (as % of commercial service exports) in Niger in 2006 to that in 2011?
Make the answer very short. 1.35. What is the ratio of the Balance of Payment (as % of commercial service exports) of Heavily indebted poor countries in 2006 to that in 2012?
Keep it short and to the point. 0.97. What is the ratio of the Balance of Payment (as % of commercial service exports) of Cyprus in 2006 to that in 2012?
Offer a very short reply. 1.02. What is the ratio of the Balance of Payment (as % of commercial service exports) of Niger in 2006 to that in 2012?
Make the answer very short. 2.11. What is the ratio of the Balance of Payment (as % of commercial service exports) in Heavily indebted poor countries in 2007 to that in 2008?
Give a very brief answer. 0.99. What is the ratio of the Balance of Payment (as % of commercial service exports) of Cyprus in 2007 to that in 2008?
Ensure brevity in your answer.  0.91. What is the ratio of the Balance of Payment (as % of commercial service exports) of Niger in 2007 to that in 2008?
Your answer should be compact. 1.57. What is the ratio of the Balance of Payment (as % of commercial service exports) in Heavily indebted poor countries in 2007 to that in 2009?
Your answer should be compact. 0.96. What is the ratio of the Balance of Payment (as % of commercial service exports) of Cyprus in 2007 to that in 2009?
Make the answer very short. 0.91. What is the ratio of the Balance of Payment (as % of commercial service exports) of Niger in 2007 to that in 2009?
Ensure brevity in your answer.  1.9. What is the ratio of the Balance of Payment (as % of commercial service exports) of Heavily indebted poor countries in 2007 to that in 2010?
Keep it short and to the point. 0.9. What is the ratio of the Balance of Payment (as % of commercial service exports) of Niger in 2007 to that in 2010?
Your response must be concise. 21.22. What is the ratio of the Balance of Payment (as % of commercial service exports) of Heavily indebted poor countries in 2007 to that in 2011?
Make the answer very short. 0.85. What is the ratio of the Balance of Payment (as % of commercial service exports) of Niger in 2007 to that in 2011?
Offer a terse response. 1.91. What is the ratio of the Balance of Payment (as % of commercial service exports) of Heavily indebted poor countries in 2007 to that in 2012?
Your answer should be compact. 0.89. What is the ratio of the Balance of Payment (as % of commercial service exports) of Cyprus in 2007 to that in 2012?
Offer a very short reply. 1.03. What is the ratio of the Balance of Payment (as % of commercial service exports) of Niger in 2007 to that in 2012?
Your answer should be very brief. 2.98. What is the ratio of the Balance of Payment (as % of commercial service exports) in Heavily indebted poor countries in 2008 to that in 2009?
Your answer should be very brief. 0.97. What is the ratio of the Balance of Payment (as % of commercial service exports) of Cyprus in 2008 to that in 2009?
Provide a succinct answer. 1.01. What is the ratio of the Balance of Payment (as % of commercial service exports) of Niger in 2008 to that in 2009?
Provide a short and direct response. 1.21. What is the ratio of the Balance of Payment (as % of commercial service exports) in Heavily indebted poor countries in 2008 to that in 2010?
Provide a succinct answer. 0.91. What is the ratio of the Balance of Payment (as % of commercial service exports) of Cyprus in 2008 to that in 2010?
Your answer should be compact. 1.1. What is the ratio of the Balance of Payment (as % of commercial service exports) of Niger in 2008 to that in 2010?
Provide a succinct answer. 13.55. What is the ratio of the Balance of Payment (as % of commercial service exports) of Heavily indebted poor countries in 2008 to that in 2011?
Offer a very short reply. 0.86. What is the ratio of the Balance of Payment (as % of commercial service exports) in Cyprus in 2008 to that in 2011?
Offer a terse response. 1.1. What is the ratio of the Balance of Payment (as % of commercial service exports) of Niger in 2008 to that in 2011?
Provide a short and direct response. 1.22. What is the ratio of the Balance of Payment (as % of commercial service exports) in Heavily indebted poor countries in 2008 to that in 2012?
Your response must be concise. 0.9. What is the ratio of the Balance of Payment (as % of commercial service exports) in Cyprus in 2008 to that in 2012?
Provide a succinct answer. 1.14. What is the ratio of the Balance of Payment (as % of commercial service exports) in Niger in 2008 to that in 2012?
Your answer should be compact. 1.9. What is the ratio of the Balance of Payment (as % of commercial service exports) of Cyprus in 2009 to that in 2010?
Your response must be concise. 1.09. What is the ratio of the Balance of Payment (as % of commercial service exports) in Niger in 2009 to that in 2010?
Offer a very short reply. 11.18. What is the ratio of the Balance of Payment (as % of commercial service exports) of Heavily indebted poor countries in 2009 to that in 2011?
Provide a short and direct response. 0.89. What is the ratio of the Balance of Payment (as % of commercial service exports) of Cyprus in 2009 to that in 2011?
Make the answer very short. 1.09. What is the ratio of the Balance of Payment (as % of commercial service exports) in Niger in 2009 to that in 2011?
Offer a very short reply. 1. What is the ratio of the Balance of Payment (as % of commercial service exports) of Heavily indebted poor countries in 2009 to that in 2012?
Provide a short and direct response. 0.93. What is the ratio of the Balance of Payment (as % of commercial service exports) in Cyprus in 2009 to that in 2012?
Give a very brief answer. 1.13. What is the ratio of the Balance of Payment (as % of commercial service exports) in Niger in 2009 to that in 2012?
Your response must be concise. 1.57. What is the ratio of the Balance of Payment (as % of commercial service exports) in Heavily indebted poor countries in 2010 to that in 2011?
Give a very brief answer. 0.94. What is the ratio of the Balance of Payment (as % of commercial service exports) in Niger in 2010 to that in 2011?
Make the answer very short. 0.09. What is the ratio of the Balance of Payment (as % of commercial service exports) in Cyprus in 2010 to that in 2012?
Offer a very short reply. 1.03. What is the ratio of the Balance of Payment (as % of commercial service exports) of Niger in 2010 to that in 2012?
Ensure brevity in your answer.  0.14. What is the ratio of the Balance of Payment (as % of commercial service exports) of Heavily indebted poor countries in 2011 to that in 2012?
Offer a very short reply. 1.05. What is the ratio of the Balance of Payment (as % of commercial service exports) in Cyprus in 2011 to that in 2012?
Offer a very short reply. 1.03. What is the ratio of the Balance of Payment (as % of commercial service exports) in Niger in 2011 to that in 2012?
Give a very brief answer. 1.56. What is the difference between the highest and the second highest Balance of Payment (as % of commercial service exports) of Heavily indebted poor countries?
Ensure brevity in your answer.  0.85. What is the difference between the highest and the second highest Balance of Payment (as % of commercial service exports) in Cyprus?
Your response must be concise. 0.28. What is the difference between the highest and the second highest Balance of Payment (as % of commercial service exports) of Niger?
Your answer should be very brief. 4.32. What is the difference between the highest and the lowest Balance of Payment (as % of commercial service exports) of Heavily indebted poor countries?
Give a very brief answer. 2.79. What is the difference between the highest and the lowest Balance of Payment (as % of commercial service exports) in Cyprus?
Offer a terse response. 3.61. What is the difference between the highest and the lowest Balance of Payment (as % of commercial service exports) of Niger?
Offer a terse response. 14.15. 